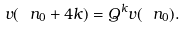Convert formula to latex. <formula><loc_0><loc_0><loc_500><loc_500>v ( \ n _ { 0 } + 4 k ) = Q ^ { k } v ( \ n _ { 0 } ) .</formula> 